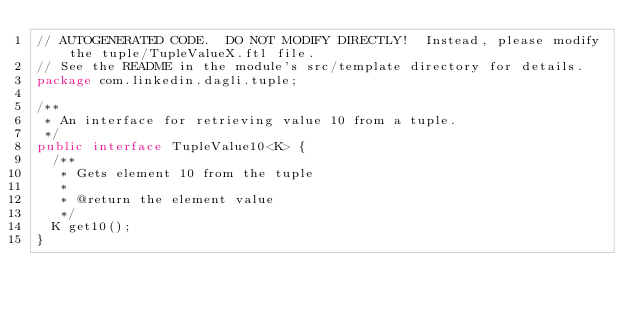<code> <loc_0><loc_0><loc_500><loc_500><_Java_>// AUTOGENERATED CODE.  DO NOT MODIFY DIRECTLY!  Instead, please modify the tuple/TupleValueX.ftl file.
// See the README in the module's src/template directory for details.
package com.linkedin.dagli.tuple;

/**
 * An interface for retrieving value 10 from a tuple.
 */
public interface TupleValue10<K> {
  /**
   * Gets element 10 from the tuple
   *
   * @return the element value
   */
  K get10();
}
</code> 